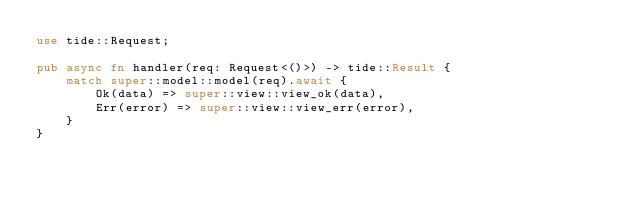Convert code to text. <code><loc_0><loc_0><loc_500><loc_500><_Rust_>use tide::Request;

pub async fn handler(req: Request<()>) -> tide::Result {
    match super::model::model(req).await {
        Ok(data) => super::view::view_ok(data),
        Err(error) => super::view::view_err(error),
    }
}
</code> 